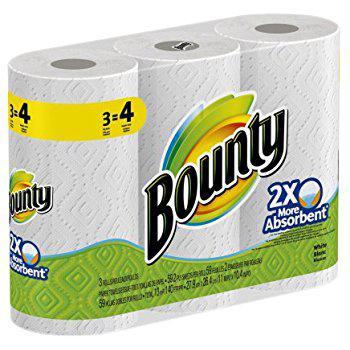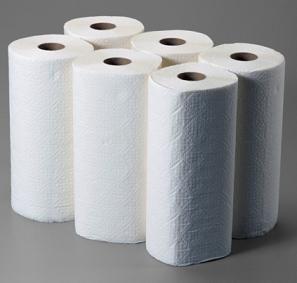The first image is the image on the left, the second image is the image on the right. For the images displayed, is the sentence "There is exactly one roll of paper towels in the image on the left." factually correct? Answer yes or no. No. 